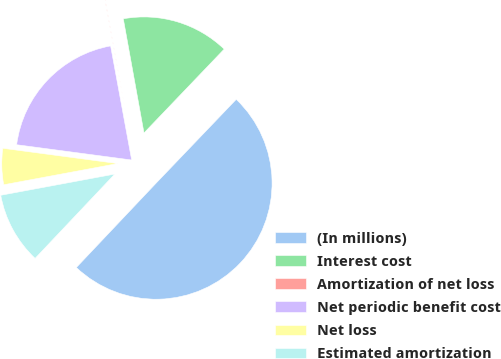<chart> <loc_0><loc_0><loc_500><loc_500><pie_chart><fcel>(In millions)<fcel>Interest cost<fcel>Amortization of net loss<fcel>Net periodic benefit cost<fcel>Net loss<fcel>Estimated amortization<nl><fcel>49.9%<fcel>15.0%<fcel>0.05%<fcel>19.99%<fcel>5.03%<fcel>10.02%<nl></chart> 